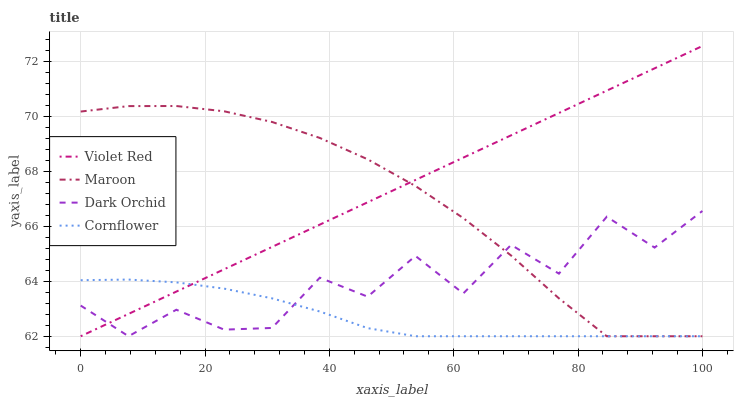Does Cornflower have the minimum area under the curve?
Answer yes or no. Yes. Does Violet Red have the maximum area under the curve?
Answer yes or no. Yes. Does Dark Orchid have the minimum area under the curve?
Answer yes or no. No. Does Dark Orchid have the maximum area under the curve?
Answer yes or no. No. Is Violet Red the smoothest?
Answer yes or no. Yes. Is Dark Orchid the roughest?
Answer yes or no. Yes. Is Dark Orchid the smoothest?
Answer yes or no. No. Is Violet Red the roughest?
Answer yes or no. No. Does Cornflower have the lowest value?
Answer yes or no. Yes. Does Violet Red have the highest value?
Answer yes or no. Yes. Does Dark Orchid have the highest value?
Answer yes or no. No. Does Dark Orchid intersect Cornflower?
Answer yes or no. Yes. Is Dark Orchid less than Cornflower?
Answer yes or no. No. Is Dark Orchid greater than Cornflower?
Answer yes or no. No. 